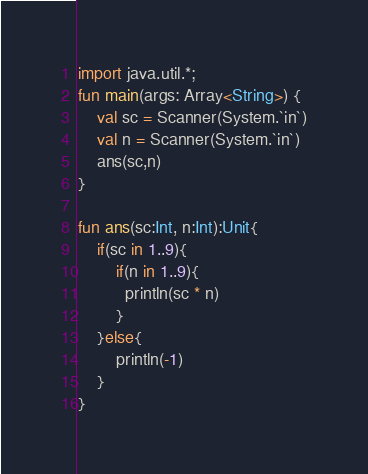Convert code to text. <code><loc_0><loc_0><loc_500><loc_500><_Kotlin_>import java.util.*;
fun main(args: Array<String>) {
    val sc = Scanner(System.`in`)
    val n = Scanner(System.`in`)
    ans(sc,n)
}
 
fun ans(sc:Int, n:Int):Unit{
    if(sc in 1..9){
        if(n in 1..9){
          println(sc * n)       
        }
    }else{
    	println(-1)
    }
}</code> 